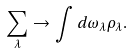<formula> <loc_0><loc_0><loc_500><loc_500>\sum _ { \lambda } \rightarrow \int d \omega _ { \lambda } \rho _ { \lambda } .</formula> 